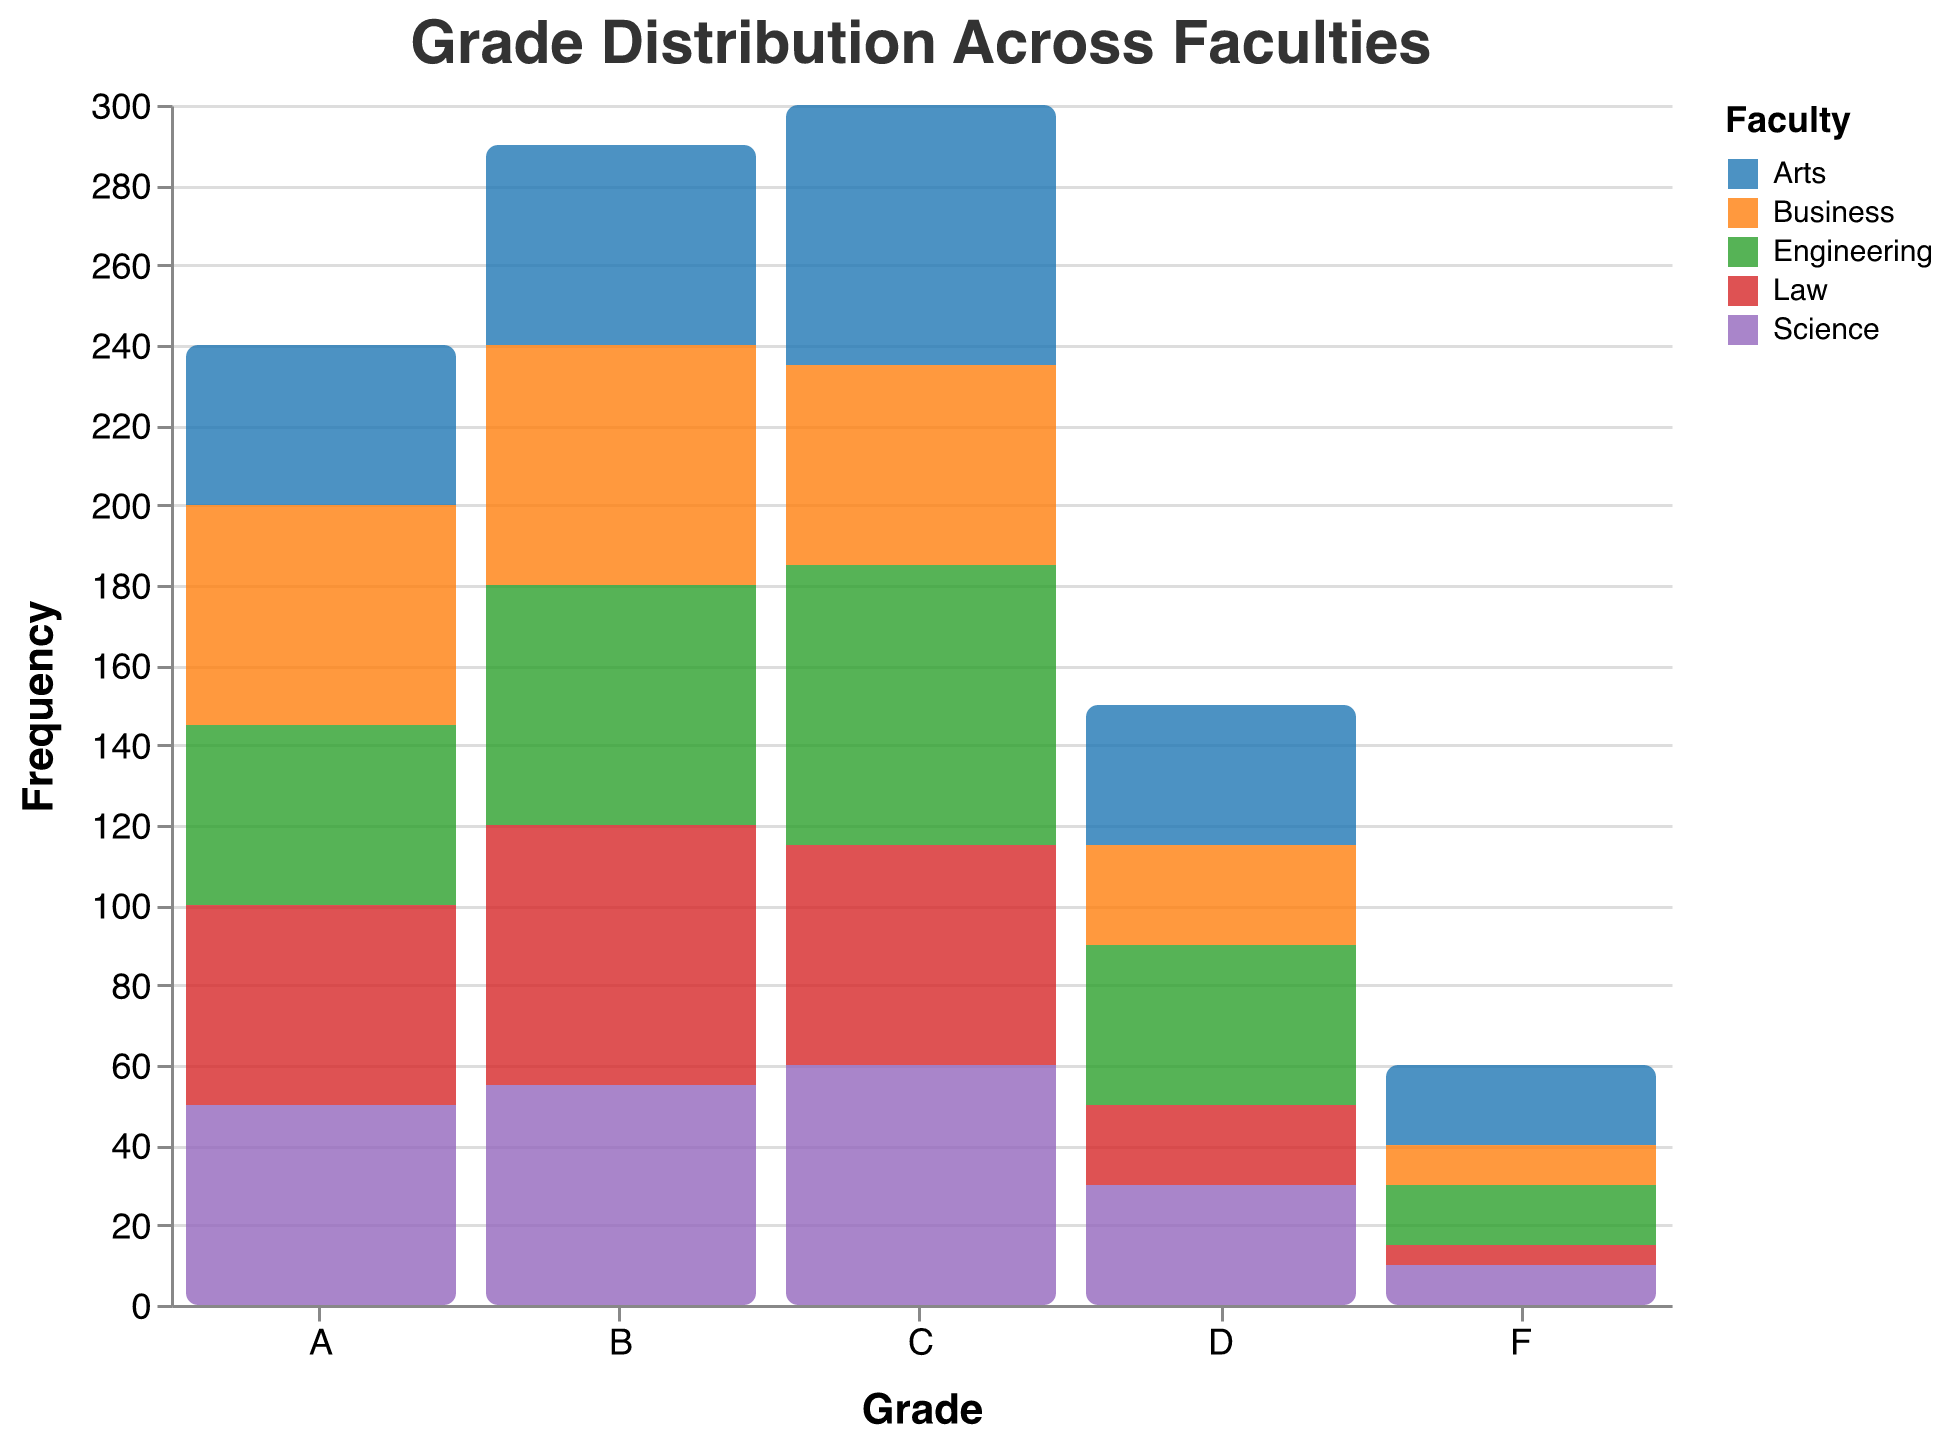What is the title of the figure? The title can be found at the top of the figure. The title says, "Grade Distribution Across Faculties."
Answer: Grade Distribution Across Faculties How many grades are represented in the figure? The x-axis shows the different grades, which are A, B, C, D, and F.
Answer: 5 Which faculty has the highest frequency of students with grade C? By looking at the bars representing grade C, the Engineering faculty has the tallest bar, indicating the highest frequency.
Answer: Engineering What is the total frequency of students with grade F across all faculties? Add the frequency values of grade F for each faculty: 15 (Engineering) + 10 (Science) + 20 (Arts) + 10 (Business) + 5 (Law) = 60.
Answer: 60 Which grade has the highest frequency in the Business faculty? By looking at the color representing Business, the tallest bar for the Business faculty is for grade B.
Answer: B Compare the number of students with grade A in Science and Law faculties. Which is higher? Looking at the bars for Science and Law, both show an equal frequency of 50 for grade A.
Answer: Equal What is the difference in frequency of grade D between Arts and Law faculties? The frequency of grade D in Arts is 35, and in Law it is 20. The difference is 35 - 20 = 15.
Answer: 15 Which faculty has the least number of students with grade F? By observing the bars for grade F across all faculties, the Law faculty has the shortest bar with a frequency of 5.
Answer: Law Among all faculties, which grade has the lowest overall frequency? By summing the frequencies for grade F: 15, 10, 20, 10, and 5 across all faculties, it totals 60, which is the lowest overall compared to other grades.
Answer: F What is the average frequency of grade B across all faculties? Add the frequencies of grade B for all faculties and divide by the number of faculties: (60 + 55 + 50 + 60 + 65) / 5 = 290 / 5 = 58.
Answer: 58 